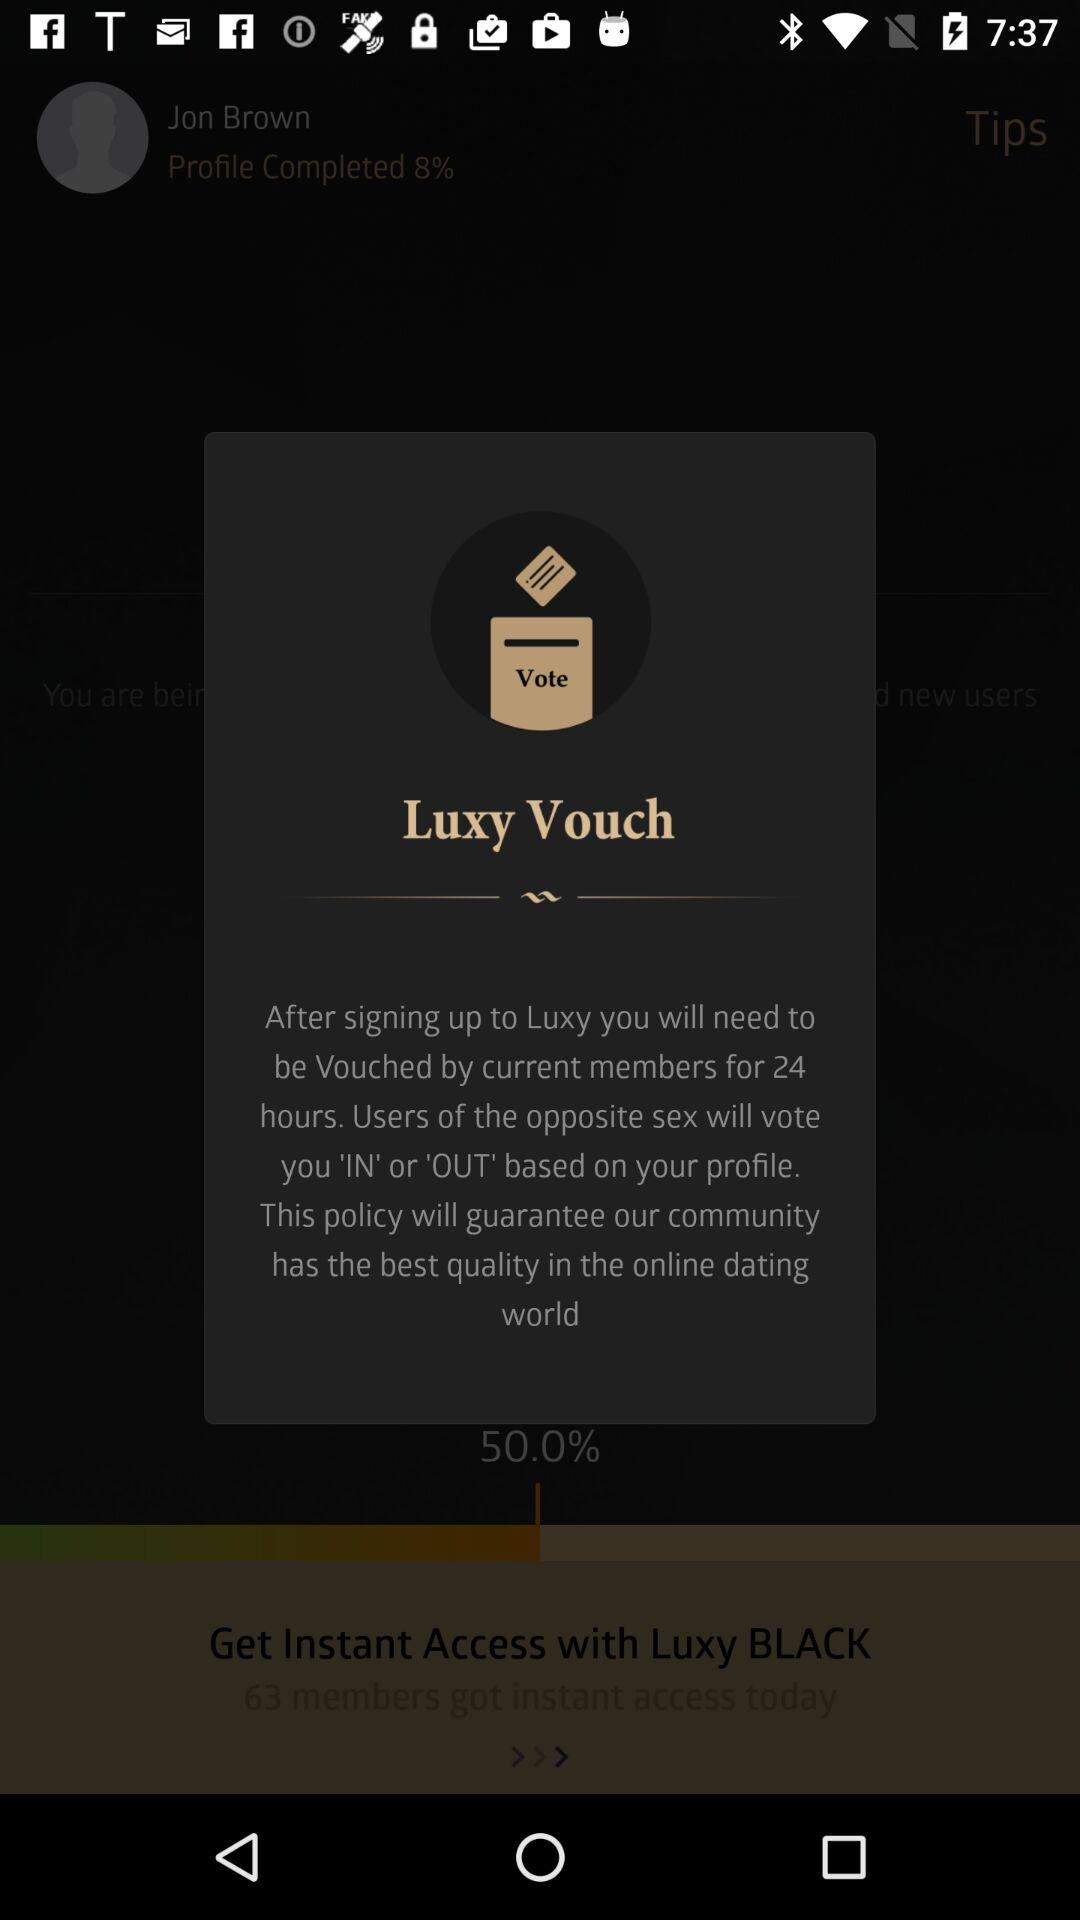What is the percentage of the user's profile completed?
Answer the question using a single word or phrase. 8% 